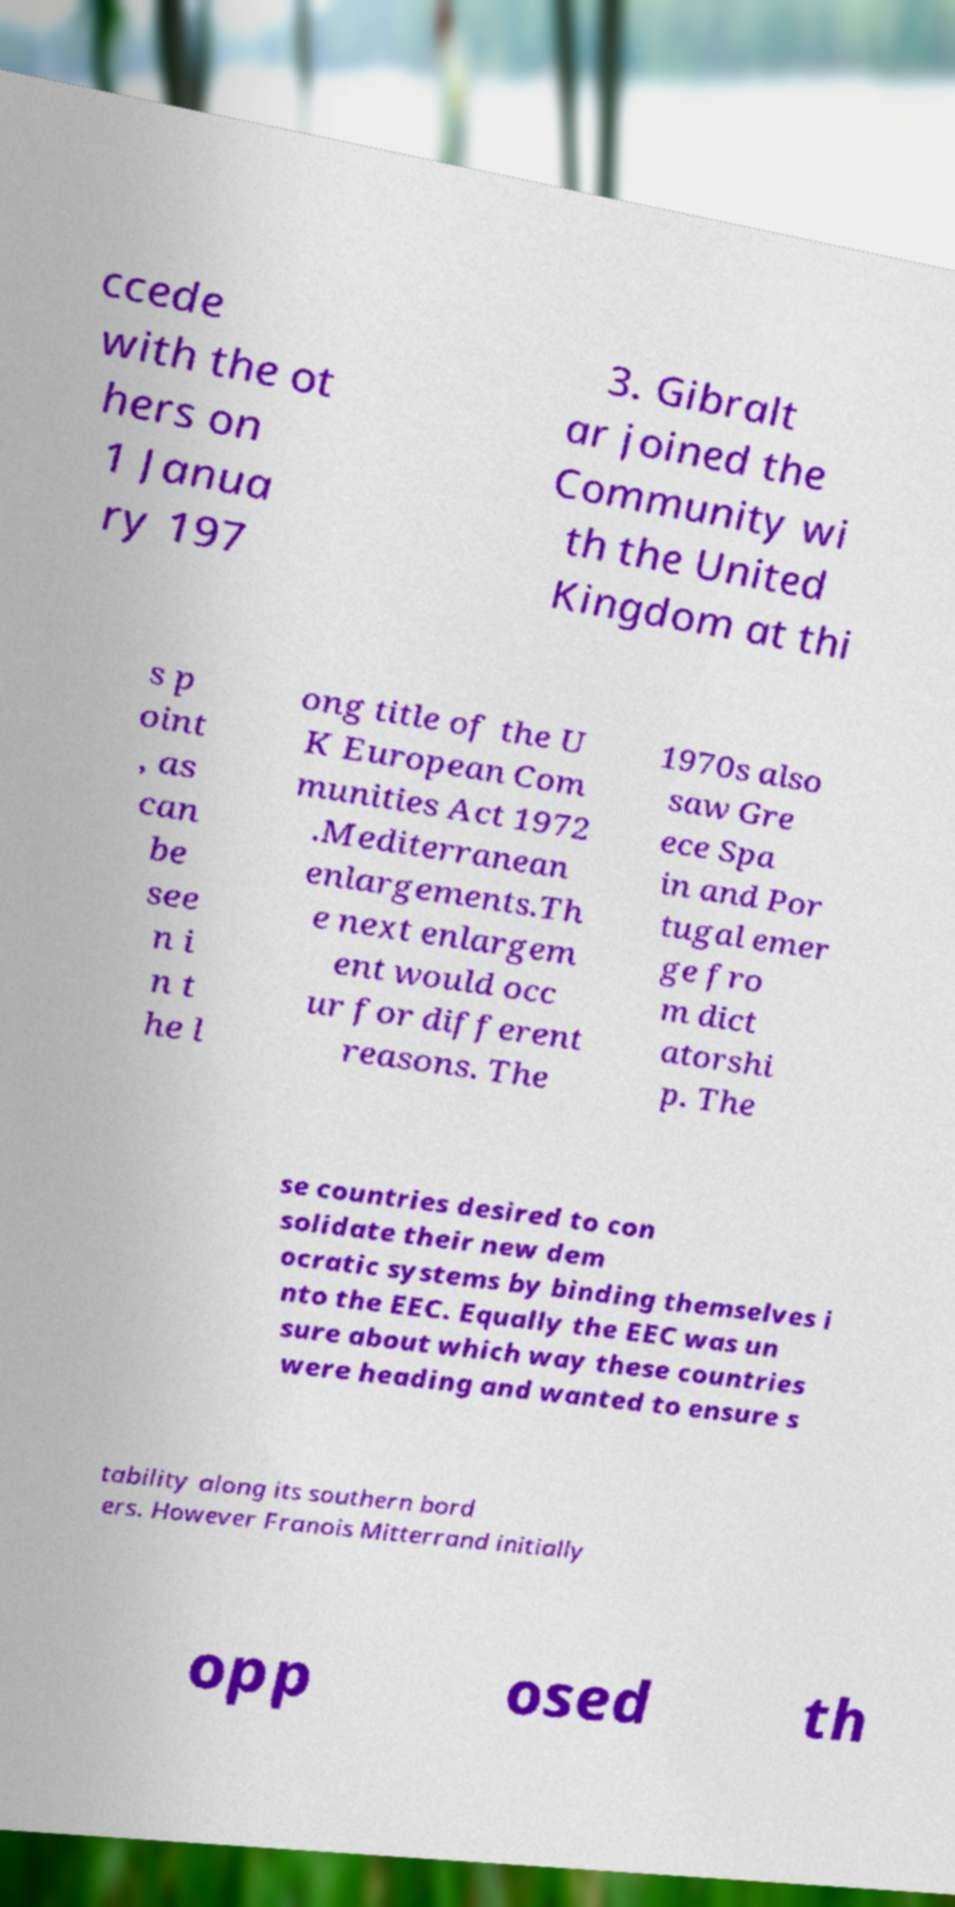For documentation purposes, I need the text within this image transcribed. Could you provide that? ccede with the ot hers on 1 Janua ry 197 3. Gibralt ar joined the Community wi th the United Kingdom at thi s p oint , as can be see n i n t he l ong title of the U K European Com munities Act 1972 .Mediterranean enlargements.Th e next enlargem ent would occ ur for different reasons. The 1970s also saw Gre ece Spa in and Por tugal emer ge fro m dict atorshi p. The se countries desired to con solidate their new dem ocratic systems by binding themselves i nto the EEC. Equally the EEC was un sure about which way these countries were heading and wanted to ensure s tability along its southern bord ers. However Franois Mitterrand initially opp osed th 